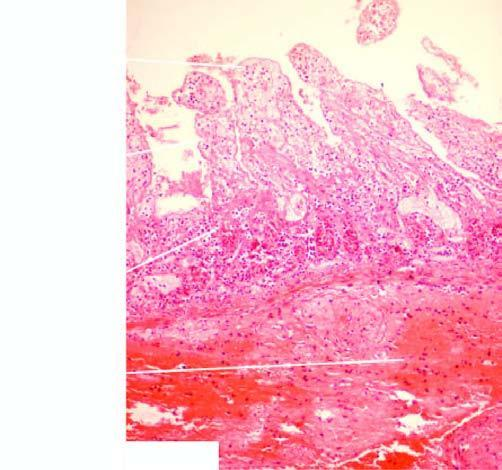s muscularis also partly affected?
Answer the question using a single word or phrase. Yes 